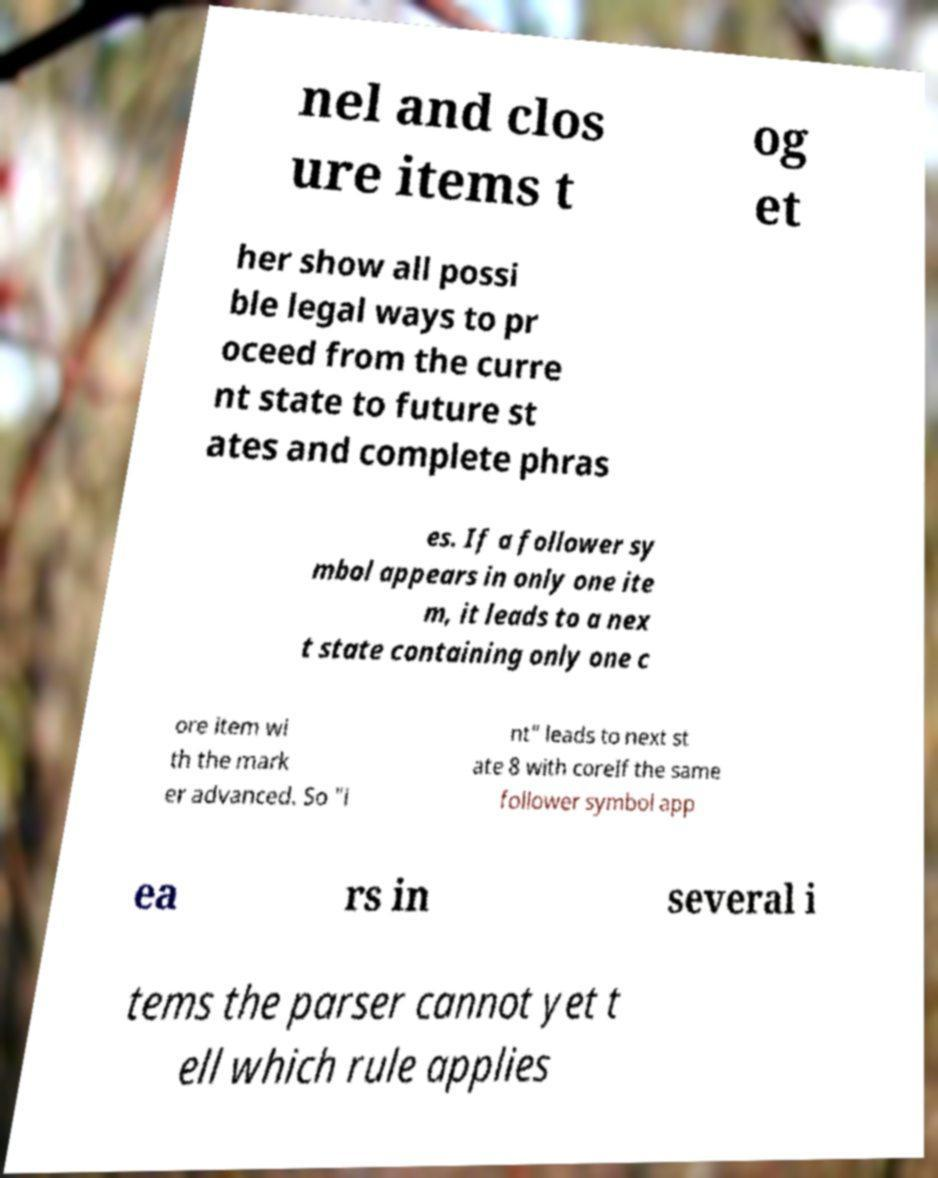I need the written content from this picture converted into text. Can you do that? nel and clos ure items t og et her show all possi ble legal ways to pr oceed from the curre nt state to future st ates and complete phras es. If a follower sy mbol appears in only one ite m, it leads to a nex t state containing only one c ore item wi th the mark er advanced. So "i nt" leads to next st ate 8 with coreIf the same follower symbol app ea rs in several i tems the parser cannot yet t ell which rule applies 